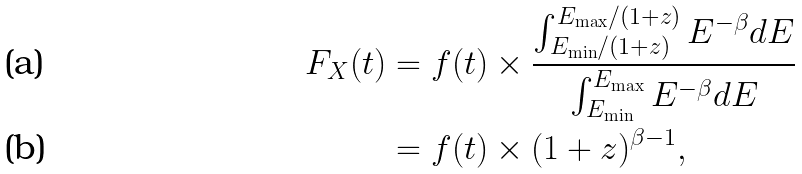<formula> <loc_0><loc_0><loc_500><loc_500>F _ { X } ( t ) & = f ( t ) \times \frac { \int _ { E _ { \min } / ( 1 + z ) } ^ { E _ { \max } / ( 1 + z ) } E ^ { - \beta } d E } { \int _ { E _ { \min } } ^ { E _ { \max } } E ^ { - \beta } d E } \\ & = f ( t ) \times ( 1 + z ) ^ { \beta - 1 } ,</formula> 